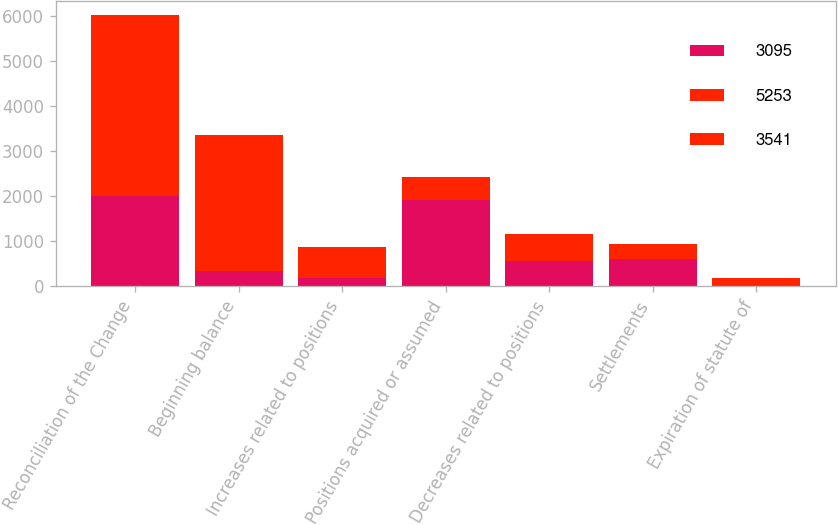Convert chart to OTSL. <chart><loc_0><loc_0><loc_500><loc_500><stacked_bar_chart><ecel><fcel>Reconciliation of the Change<fcel>Beginning balance<fcel>Increases related to positions<fcel>Positions acquired or assumed<fcel>Decreases related to positions<fcel>Settlements<fcel>Expiration of statute of<nl><fcel>3095<fcel>2009<fcel>349.5<fcel>181<fcel>1924<fcel>554<fcel>615<fcel>15<nl><fcel>5253<fcel>2008<fcel>349.5<fcel>241<fcel>169<fcel>371<fcel>209<fcel>72<nl><fcel>3541<fcel>2007<fcel>2667<fcel>456<fcel>328<fcel>227<fcel>108<fcel>88<nl></chart> 